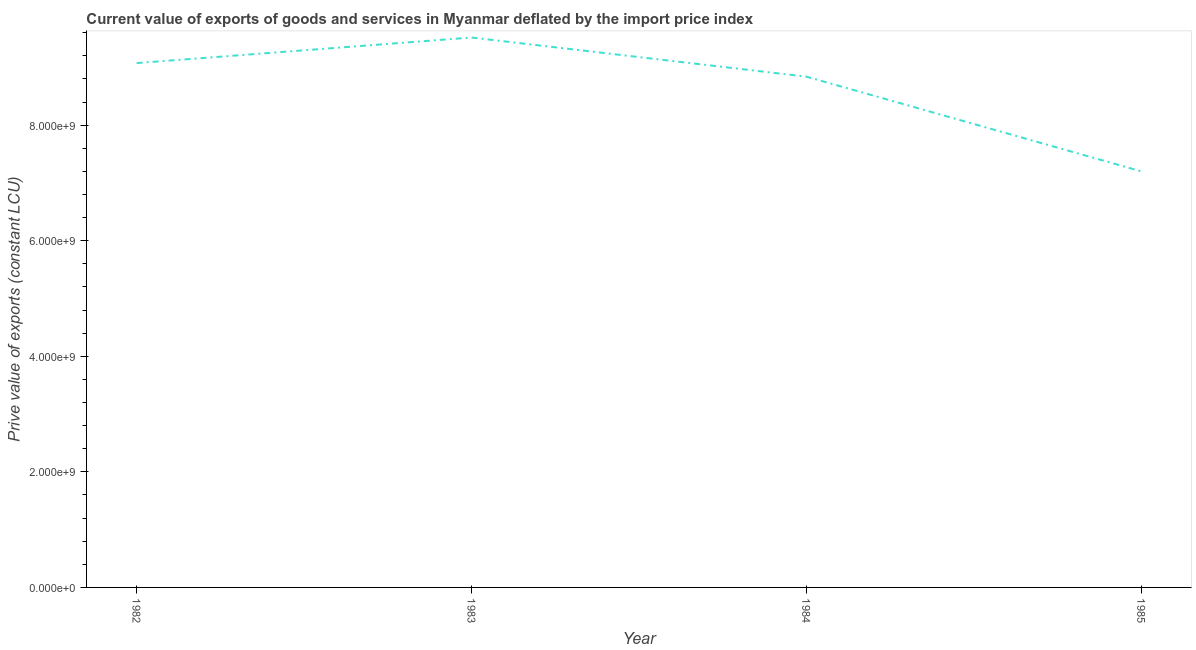What is the price value of exports in 1982?
Keep it short and to the point. 9.07e+09. Across all years, what is the maximum price value of exports?
Give a very brief answer. 9.52e+09. Across all years, what is the minimum price value of exports?
Ensure brevity in your answer.  7.20e+09. In which year was the price value of exports maximum?
Your response must be concise. 1983. What is the sum of the price value of exports?
Provide a succinct answer. 3.46e+1. What is the difference between the price value of exports in 1982 and 1984?
Your response must be concise. 2.35e+08. What is the average price value of exports per year?
Keep it short and to the point. 8.66e+09. What is the median price value of exports?
Provide a short and direct response. 8.96e+09. Do a majority of the years between 1982 and 1983 (inclusive) have price value of exports greater than 1600000000 LCU?
Keep it short and to the point. Yes. What is the ratio of the price value of exports in 1982 to that in 1985?
Give a very brief answer. 1.26. What is the difference between the highest and the second highest price value of exports?
Your answer should be compact. 4.42e+08. What is the difference between the highest and the lowest price value of exports?
Give a very brief answer. 2.32e+09. Does the price value of exports monotonically increase over the years?
Keep it short and to the point. No. Are the values on the major ticks of Y-axis written in scientific E-notation?
Your answer should be compact. Yes. Does the graph contain grids?
Your answer should be very brief. No. What is the title of the graph?
Your answer should be compact. Current value of exports of goods and services in Myanmar deflated by the import price index. What is the label or title of the Y-axis?
Your answer should be compact. Prive value of exports (constant LCU). What is the Prive value of exports (constant LCU) of 1982?
Offer a terse response. 9.07e+09. What is the Prive value of exports (constant LCU) in 1983?
Give a very brief answer. 9.52e+09. What is the Prive value of exports (constant LCU) of 1984?
Provide a short and direct response. 8.84e+09. What is the Prive value of exports (constant LCU) in 1985?
Your response must be concise. 7.20e+09. What is the difference between the Prive value of exports (constant LCU) in 1982 and 1983?
Your answer should be compact. -4.42e+08. What is the difference between the Prive value of exports (constant LCU) in 1982 and 1984?
Ensure brevity in your answer.  2.35e+08. What is the difference between the Prive value of exports (constant LCU) in 1982 and 1985?
Your response must be concise. 1.87e+09. What is the difference between the Prive value of exports (constant LCU) in 1983 and 1984?
Keep it short and to the point. 6.77e+08. What is the difference between the Prive value of exports (constant LCU) in 1983 and 1985?
Provide a short and direct response. 2.32e+09. What is the difference between the Prive value of exports (constant LCU) in 1984 and 1985?
Your answer should be compact. 1.64e+09. What is the ratio of the Prive value of exports (constant LCU) in 1982 to that in 1983?
Provide a short and direct response. 0.95. What is the ratio of the Prive value of exports (constant LCU) in 1982 to that in 1985?
Offer a very short reply. 1.26. What is the ratio of the Prive value of exports (constant LCU) in 1983 to that in 1984?
Your response must be concise. 1.08. What is the ratio of the Prive value of exports (constant LCU) in 1983 to that in 1985?
Your response must be concise. 1.32. What is the ratio of the Prive value of exports (constant LCU) in 1984 to that in 1985?
Keep it short and to the point. 1.23. 